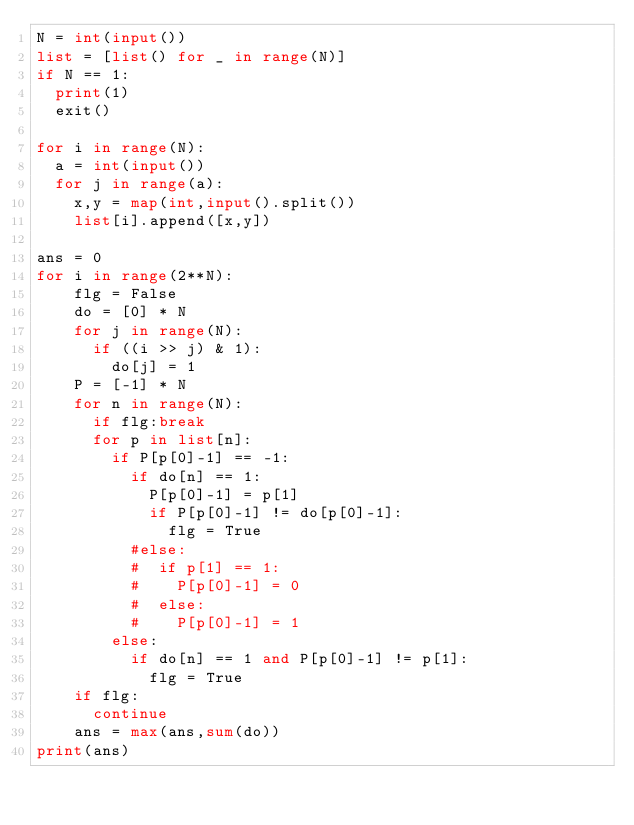Convert code to text. <code><loc_0><loc_0><loc_500><loc_500><_Python_>N = int(input())
list = [list() for _ in range(N)]
if N == 1:
  print(1)
  exit()

for i in range(N):
  a = int(input())
  for j in range(a):
    x,y = map(int,input().split())
    list[i].append([x,y])

ans = 0
for i in range(2**N):
    flg = False
    do = [0] * N
    for j in range(N):
      if ((i >> j) & 1):
        do[j] = 1
    P = [-1] * N
    for n in range(N):
      if flg:break
      for p in list[n]:
        if P[p[0]-1] == -1:
          if do[n] == 1:
            P[p[0]-1] = p[1]
            if P[p[0]-1] != do[p[0]-1]:
              flg = True
          #else:
          #  if p[1] == 1:
          #    P[p[0]-1] = 0
          #  else:
          #    P[p[0]-1] = 1
        else:
          if do[n] == 1 and P[p[0]-1] != p[1]:
            flg = True
    if flg:
      continue
    ans = max(ans,sum(do))
print(ans)



</code> 